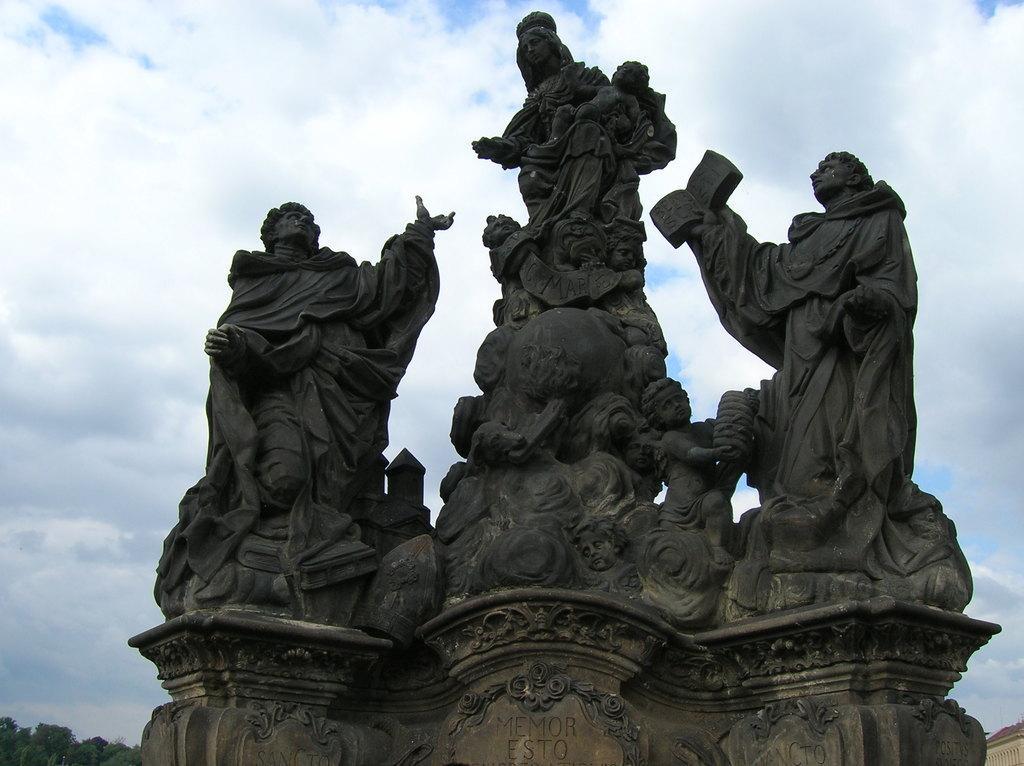Describe this image in one or two sentences. In this image, we can see some statues with text written. We can see some trees on the bottom left corner. We can see the sky with clouds. We can also see an object on the bottom right. 